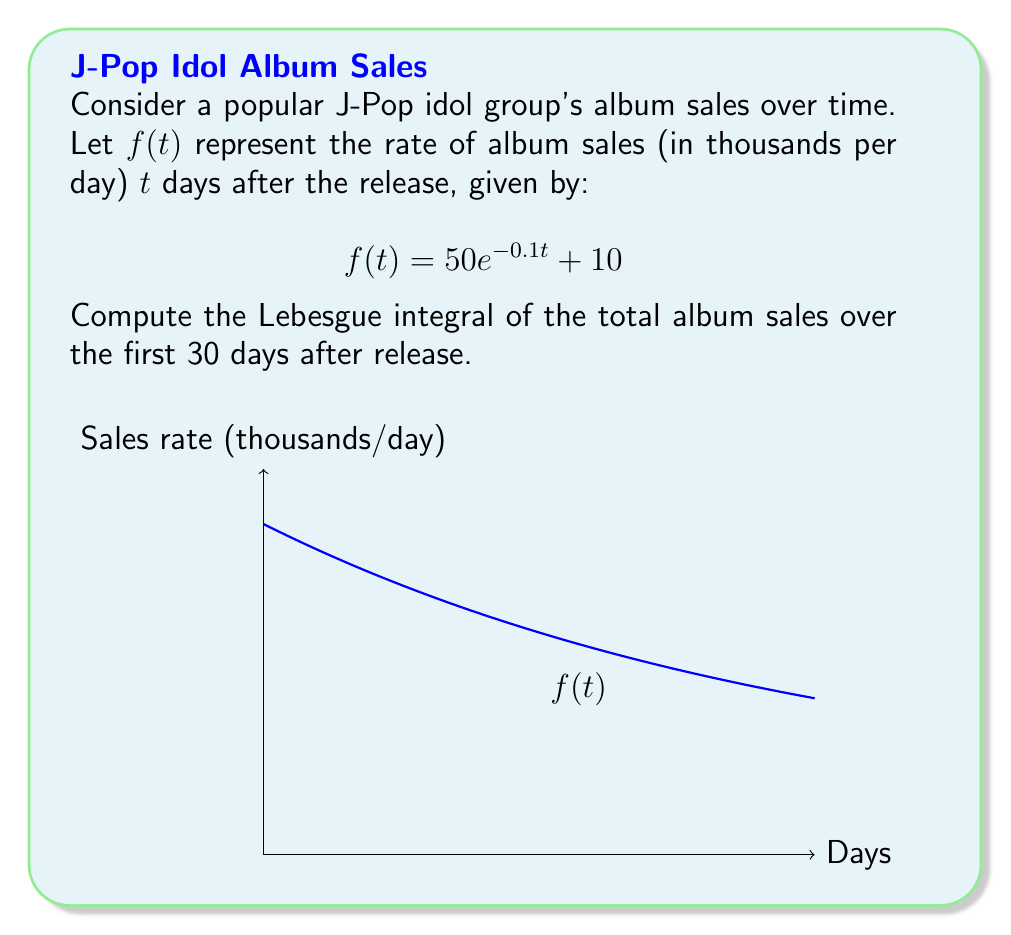Solve this math problem. To solve this problem, we'll follow these steps:

1) The Lebesgue integral in this case is equivalent to the Riemann integral since $f(t)$ is a continuous function on a closed interval $[0,30]$.

2) We need to calculate:

   $$\int_0^{30} f(t) dt = \int_0^{30} (50e^{-0.1t} + 10) dt$$

3) Let's split this into two integrals:

   $$\int_0^{30} 50e^{-0.1t} dt + \int_0^{30} 10 dt$$

4) For the first integral:
   
   $$\int 50e^{-0.1t} dt = -500e^{-0.1t} + C$$

   Evaluating from 0 to 30:

   $$[-500e^{-0.1t}]_0^{30} = -500e^{-3} + 500 = 500(1 - e^{-3})$$

5) For the second integral:

   $$\int_0^{30} 10 dt = 10t |_0^{30} = 300$$

6) Adding the results:

   $$500(1 - e^{-3}) + 300 = 500 - 500e^{-3} + 300 = 800 - 500e^{-3}$$

This represents the total album sales (in thousands) over the 30-day period.
Answer: $800 - 500e^{-3}$ thousand albums 